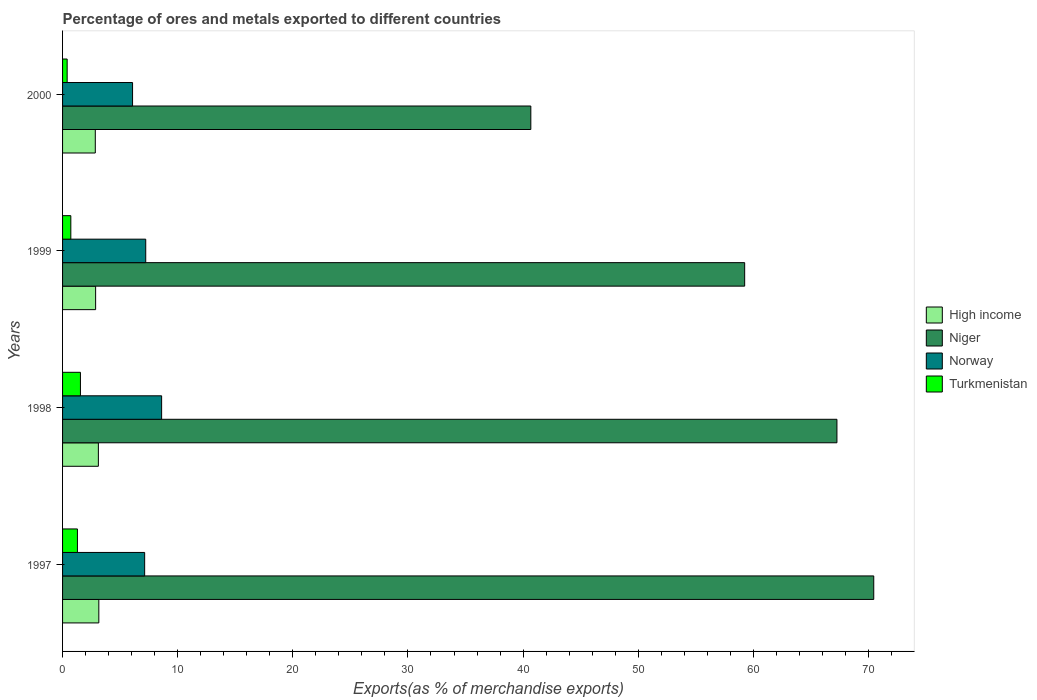How many groups of bars are there?
Your response must be concise. 4. Are the number of bars per tick equal to the number of legend labels?
Make the answer very short. Yes. How many bars are there on the 4th tick from the bottom?
Give a very brief answer. 4. What is the label of the 4th group of bars from the top?
Make the answer very short. 1997. In how many cases, is the number of bars for a given year not equal to the number of legend labels?
Keep it short and to the point. 0. What is the percentage of exports to different countries in Norway in 2000?
Make the answer very short. 6.08. Across all years, what is the maximum percentage of exports to different countries in High income?
Your answer should be very brief. 3.15. Across all years, what is the minimum percentage of exports to different countries in Norway?
Your answer should be compact. 6.08. In which year was the percentage of exports to different countries in Norway maximum?
Give a very brief answer. 1998. What is the total percentage of exports to different countries in High income in the graph?
Your answer should be very brief. 11.98. What is the difference between the percentage of exports to different countries in Norway in 1997 and that in 1998?
Provide a succinct answer. -1.47. What is the difference between the percentage of exports to different countries in Norway in 1998 and the percentage of exports to different countries in Turkmenistan in 1997?
Make the answer very short. 7.31. What is the average percentage of exports to different countries in Niger per year?
Offer a terse response. 59.41. In the year 1998, what is the difference between the percentage of exports to different countries in Niger and percentage of exports to different countries in Turkmenistan?
Keep it short and to the point. 65.71. What is the ratio of the percentage of exports to different countries in Niger in 1998 to that in 2000?
Offer a terse response. 1.65. Is the percentage of exports to different countries in Niger in 1997 less than that in 1998?
Make the answer very short. No. Is the difference between the percentage of exports to different countries in Niger in 1999 and 2000 greater than the difference between the percentage of exports to different countries in Turkmenistan in 1999 and 2000?
Keep it short and to the point. Yes. What is the difference between the highest and the second highest percentage of exports to different countries in Norway?
Provide a short and direct response. 1.38. What is the difference between the highest and the lowest percentage of exports to different countries in Norway?
Your answer should be compact. 2.52. Is the sum of the percentage of exports to different countries in High income in 1998 and 1999 greater than the maximum percentage of exports to different countries in Turkmenistan across all years?
Your response must be concise. Yes. Is it the case that in every year, the sum of the percentage of exports to different countries in High income and percentage of exports to different countries in Niger is greater than the percentage of exports to different countries in Turkmenistan?
Provide a short and direct response. Yes. What is the difference between two consecutive major ticks on the X-axis?
Your response must be concise. 10. Where does the legend appear in the graph?
Offer a very short reply. Center right. How many legend labels are there?
Provide a succinct answer. 4. How are the legend labels stacked?
Provide a short and direct response. Vertical. What is the title of the graph?
Provide a short and direct response. Percentage of ores and metals exported to different countries. Does "St. Lucia" appear as one of the legend labels in the graph?
Give a very brief answer. No. What is the label or title of the X-axis?
Your response must be concise. Exports(as % of merchandise exports). What is the Exports(as % of merchandise exports) of High income in 1997?
Offer a terse response. 3.15. What is the Exports(as % of merchandise exports) of Niger in 1997?
Keep it short and to the point. 70.46. What is the Exports(as % of merchandise exports) in Norway in 1997?
Provide a short and direct response. 7.13. What is the Exports(as % of merchandise exports) in Turkmenistan in 1997?
Make the answer very short. 1.29. What is the Exports(as % of merchandise exports) in High income in 1998?
Provide a succinct answer. 3.11. What is the Exports(as % of merchandise exports) of Niger in 1998?
Provide a short and direct response. 67.26. What is the Exports(as % of merchandise exports) in Norway in 1998?
Ensure brevity in your answer.  8.6. What is the Exports(as % of merchandise exports) in Turkmenistan in 1998?
Ensure brevity in your answer.  1.55. What is the Exports(as % of merchandise exports) in High income in 1999?
Offer a terse response. 2.87. What is the Exports(as % of merchandise exports) in Niger in 1999?
Make the answer very short. 59.25. What is the Exports(as % of merchandise exports) in Norway in 1999?
Provide a succinct answer. 7.22. What is the Exports(as % of merchandise exports) of Turkmenistan in 1999?
Give a very brief answer. 0.72. What is the Exports(as % of merchandise exports) in High income in 2000?
Offer a terse response. 2.84. What is the Exports(as % of merchandise exports) of Niger in 2000?
Give a very brief answer. 40.67. What is the Exports(as % of merchandise exports) of Norway in 2000?
Offer a terse response. 6.08. What is the Exports(as % of merchandise exports) of Turkmenistan in 2000?
Your response must be concise. 0.4. Across all years, what is the maximum Exports(as % of merchandise exports) of High income?
Make the answer very short. 3.15. Across all years, what is the maximum Exports(as % of merchandise exports) in Niger?
Make the answer very short. 70.46. Across all years, what is the maximum Exports(as % of merchandise exports) in Norway?
Ensure brevity in your answer.  8.6. Across all years, what is the maximum Exports(as % of merchandise exports) of Turkmenistan?
Keep it short and to the point. 1.55. Across all years, what is the minimum Exports(as % of merchandise exports) in High income?
Provide a short and direct response. 2.84. Across all years, what is the minimum Exports(as % of merchandise exports) in Niger?
Offer a terse response. 40.67. Across all years, what is the minimum Exports(as % of merchandise exports) of Norway?
Keep it short and to the point. 6.08. Across all years, what is the minimum Exports(as % of merchandise exports) of Turkmenistan?
Keep it short and to the point. 0.4. What is the total Exports(as % of merchandise exports) of High income in the graph?
Offer a terse response. 11.98. What is the total Exports(as % of merchandise exports) in Niger in the graph?
Provide a short and direct response. 237.64. What is the total Exports(as % of merchandise exports) in Norway in the graph?
Offer a very short reply. 29.04. What is the total Exports(as % of merchandise exports) of Turkmenistan in the graph?
Provide a succinct answer. 3.96. What is the difference between the Exports(as % of merchandise exports) of High income in 1997 and that in 1998?
Keep it short and to the point. 0.04. What is the difference between the Exports(as % of merchandise exports) in Niger in 1997 and that in 1998?
Offer a terse response. 3.2. What is the difference between the Exports(as % of merchandise exports) in Norway in 1997 and that in 1998?
Your response must be concise. -1.47. What is the difference between the Exports(as % of merchandise exports) of Turkmenistan in 1997 and that in 1998?
Offer a very short reply. -0.26. What is the difference between the Exports(as % of merchandise exports) of High income in 1997 and that in 1999?
Your answer should be very brief. 0.28. What is the difference between the Exports(as % of merchandise exports) of Niger in 1997 and that in 1999?
Provide a succinct answer. 11.21. What is the difference between the Exports(as % of merchandise exports) of Norway in 1997 and that in 1999?
Provide a short and direct response. -0.09. What is the difference between the Exports(as % of merchandise exports) of Turkmenistan in 1997 and that in 1999?
Keep it short and to the point. 0.57. What is the difference between the Exports(as % of merchandise exports) of High income in 1997 and that in 2000?
Make the answer very short. 0.31. What is the difference between the Exports(as % of merchandise exports) of Niger in 1997 and that in 2000?
Provide a short and direct response. 29.79. What is the difference between the Exports(as % of merchandise exports) of Norway in 1997 and that in 2000?
Give a very brief answer. 1.05. What is the difference between the Exports(as % of merchandise exports) of Turkmenistan in 1997 and that in 2000?
Offer a terse response. 0.89. What is the difference between the Exports(as % of merchandise exports) of High income in 1998 and that in 1999?
Your answer should be compact. 0.24. What is the difference between the Exports(as % of merchandise exports) of Niger in 1998 and that in 1999?
Ensure brevity in your answer.  8.01. What is the difference between the Exports(as % of merchandise exports) of Norway in 1998 and that in 1999?
Give a very brief answer. 1.38. What is the difference between the Exports(as % of merchandise exports) of Turkmenistan in 1998 and that in 1999?
Offer a terse response. 0.83. What is the difference between the Exports(as % of merchandise exports) in High income in 1998 and that in 2000?
Provide a short and direct response. 0.27. What is the difference between the Exports(as % of merchandise exports) in Niger in 1998 and that in 2000?
Offer a terse response. 26.59. What is the difference between the Exports(as % of merchandise exports) in Norway in 1998 and that in 2000?
Your answer should be very brief. 2.52. What is the difference between the Exports(as % of merchandise exports) of Turkmenistan in 1998 and that in 2000?
Give a very brief answer. 1.15. What is the difference between the Exports(as % of merchandise exports) in High income in 1999 and that in 2000?
Your answer should be very brief. 0.03. What is the difference between the Exports(as % of merchandise exports) of Niger in 1999 and that in 2000?
Give a very brief answer. 18.57. What is the difference between the Exports(as % of merchandise exports) in Norway in 1999 and that in 2000?
Provide a succinct answer. 1.14. What is the difference between the Exports(as % of merchandise exports) of Turkmenistan in 1999 and that in 2000?
Make the answer very short. 0.32. What is the difference between the Exports(as % of merchandise exports) of High income in 1997 and the Exports(as % of merchandise exports) of Niger in 1998?
Offer a very short reply. -64.11. What is the difference between the Exports(as % of merchandise exports) in High income in 1997 and the Exports(as % of merchandise exports) in Norway in 1998?
Offer a terse response. -5.45. What is the difference between the Exports(as % of merchandise exports) in High income in 1997 and the Exports(as % of merchandise exports) in Turkmenistan in 1998?
Offer a terse response. 1.6. What is the difference between the Exports(as % of merchandise exports) of Niger in 1997 and the Exports(as % of merchandise exports) of Norway in 1998?
Provide a short and direct response. 61.85. What is the difference between the Exports(as % of merchandise exports) of Niger in 1997 and the Exports(as % of merchandise exports) of Turkmenistan in 1998?
Your response must be concise. 68.91. What is the difference between the Exports(as % of merchandise exports) of Norway in 1997 and the Exports(as % of merchandise exports) of Turkmenistan in 1998?
Your answer should be compact. 5.58. What is the difference between the Exports(as % of merchandise exports) in High income in 1997 and the Exports(as % of merchandise exports) in Niger in 1999?
Make the answer very short. -56.1. What is the difference between the Exports(as % of merchandise exports) of High income in 1997 and the Exports(as % of merchandise exports) of Norway in 1999?
Your answer should be compact. -4.07. What is the difference between the Exports(as % of merchandise exports) of High income in 1997 and the Exports(as % of merchandise exports) of Turkmenistan in 1999?
Offer a terse response. 2.43. What is the difference between the Exports(as % of merchandise exports) in Niger in 1997 and the Exports(as % of merchandise exports) in Norway in 1999?
Offer a terse response. 63.23. What is the difference between the Exports(as % of merchandise exports) in Niger in 1997 and the Exports(as % of merchandise exports) in Turkmenistan in 1999?
Your answer should be compact. 69.74. What is the difference between the Exports(as % of merchandise exports) in Norway in 1997 and the Exports(as % of merchandise exports) in Turkmenistan in 1999?
Offer a terse response. 6.41. What is the difference between the Exports(as % of merchandise exports) of High income in 1997 and the Exports(as % of merchandise exports) of Niger in 2000?
Offer a very short reply. -37.52. What is the difference between the Exports(as % of merchandise exports) of High income in 1997 and the Exports(as % of merchandise exports) of Norway in 2000?
Provide a short and direct response. -2.93. What is the difference between the Exports(as % of merchandise exports) of High income in 1997 and the Exports(as % of merchandise exports) of Turkmenistan in 2000?
Give a very brief answer. 2.75. What is the difference between the Exports(as % of merchandise exports) in Niger in 1997 and the Exports(as % of merchandise exports) in Norway in 2000?
Provide a succinct answer. 64.38. What is the difference between the Exports(as % of merchandise exports) in Niger in 1997 and the Exports(as % of merchandise exports) in Turkmenistan in 2000?
Make the answer very short. 70.06. What is the difference between the Exports(as % of merchandise exports) of Norway in 1997 and the Exports(as % of merchandise exports) of Turkmenistan in 2000?
Offer a very short reply. 6.73. What is the difference between the Exports(as % of merchandise exports) in High income in 1998 and the Exports(as % of merchandise exports) in Niger in 1999?
Make the answer very short. -56.14. What is the difference between the Exports(as % of merchandise exports) in High income in 1998 and the Exports(as % of merchandise exports) in Norway in 1999?
Provide a succinct answer. -4.11. What is the difference between the Exports(as % of merchandise exports) in High income in 1998 and the Exports(as % of merchandise exports) in Turkmenistan in 1999?
Your answer should be compact. 2.39. What is the difference between the Exports(as % of merchandise exports) in Niger in 1998 and the Exports(as % of merchandise exports) in Norway in 1999?
Your answer should be very brief. 60.04. What is the difference between the Exports(as % of merchandise exports) in Niger in 1998 and the Exports(as % of merchandise exports) in Turkmenistan in 1999?
Offer a terse response. 66.54. What is the difference between the Exports(as % of merchandise exports) in Norway in 1998 and the Exports(as % of merchandise exports) in Turkmenistan in 1999?
Ensure brevity in your answer.  7.89. What is the difference between the Exports(as % of merchandise exports) of High income in 1998 and the Exports(as % of merchandise exports) of Niger in 2000?
Offer a very short reply. -37.56. What is the difference between the Exports(as % of merchandise exports) of High income in 1998 and the Exports(as % of merchandise exports) of Norway in 2000?
Ensure brevity in your answer.  -2.97. What is the difference between the Exports(as % of merchandise exports) of High income in 1998 and the Exports(as % of merchandise exports) of Turkmenistan in 2000?
Your response must be concise. 2.71. What is the difference between the Exports(as % of merchandise exports) in Niger in 1998 and the Exports(as % of merchandise exports) in Norway in 2000?
Give a very brief answer. 61.18. What is the difference between the Exports(as % of merchandise exports) in Niger in 1998 and the Exports(as % of merchandise exports) in Turkmenistan in 2000?
Ensure brevity in your answer.  66.86. What is the difference between the Exports(as % of merchandise exports) of Norway in 1998 and the Exports(as % of merchandise exports) of Turkmenistan in 2000?
Ensure brevity in your answer.  8.21. What is the difference between the Exports(as % of merchandise exports) in High income in 1999 and the Exports(as % of merchandise exports) in Niger in 2000?
Make the answer very short. -37.8. What is the difference between the Exports(as % of merchandise exports) in High income in 1999 and the Exports(as % of merchandise exports) in Norway in 2000?
Your response must be concise. -3.21. What is the difference between the Exports(as % of merchandise exports) in High income in 1999 and the Exports(as % of merchandise exports) in Turkmenistan in 2000?
Your answer should be compact. 2.47. What is the difference between the Exports(as % of merchandise exports) in Niger in 1999 and the Exports(as % of merchandise exports) in Norway in 2000?
Provide a succinct answer. 53.17. What is the difference between the Exports(as % of merchandise exports) in Niger in 1999 and the Exports(as % of merchandise exports) in Turkmenistan in 2000?
Offer a terse response. 58.85. What is the difference between the Exports(as % of merchandise exports) in Norway in 1999 and the Exports(as % of merchandise exports) in Turkmenistan in 2000?
Your response must be concise. 6.82. What is the average Exports(as % of merchandise exports) in High income per year?
Your response must be concise. 2.99. What is the average Exports(as % of merchandise exports) of Niger per year?
Keep it short and to the point. 59.41. What is the average Exports(as % of merchandise exports) in Norway per year?
Offer a terse response. 7.26. In the year 1997, what is the difference between the Exports(as % of merchandise exports) of High income and Exports(as % of merchandise exports) of Niger?
Offer a very short reply. -67.31. In the year 1997, what is the difference between the Exports(as % of merchandise exports) in High income and Exports(as % of merchandise exports) in Norway?
Offer a terse response. -3.98. In the year 1997, what is the difference between the Exports(as % of merchandise exports) in High income and Exports(as % of merchandise exports) in Turkmenistan?
Provide a succinct answer. 1.86. In the year 1997, what is the difference between the Exports(as % of merchandise exports) in Niger and Exports(as % of merchandise exports) in Norway?
Offer a terse response. 63.33. In the year 1997, what is the difference between the Exports(as % of merchandise exports) in Niger and Exports(as % of merchandise exports) in Turkmenistan?
Provide a short and direct response. 69.17. In the year 1997, what is the difference between the Exports(as % of merchandise exports) in Norway and Exports(as % of merchandise exports) in Turkmenistan?
Provide a succinct answer. 5.84. In the year 1998, what is the difference between the Exports(as % of merchandise exports) of High income and Exports(as % of merchandise exports) of Niger?
Your response must be concise. -64.15. In the year 1998, what is the difference between the Exports(as % of merchandise exports) of High income and Exports(as % of merchandise exports) of Norway?
Keep it short and to the point. -5.49. In the year 1998, what is the difference between the Exports(as % of merchandise exports) of High income and Exports(as % of merchandise exports) of Turkmenistan?
Offer a very short reply. 1.56. In the year 1998, what is the difference between the Exports(as % of merchandise exports) of Niger and Exports(as % of merchandise exports) of Norway?
Give a very brief answer. 58.66. In the year 1998, what is the difference between the Exports(as % of merchandise exports) in Niger and Exports(as % of merchandise exports) in Turkmenistan?
Provide a succinct answer. 65.71. In the year 1998, what is the difference between the Exports(as % of merchandise exports) of Norway and Exports(as % of merchandise exports) of Turkmenistan?
Offer a very short reply. 7.05. In the year 1999, what is the difference between the Exports(as % of merchandise exports) of High income and Exports(as % of merchandise exports) of Niger?
Your answer should be compact. -56.38. In the year 1999, what is the difference between the Exports(as % of merchandise exports) in High income and Exports(as % of merchandise exports) in Norway?
Ensure brevity in your answer.  -4.35. In the year 1999, what is the difference between the Exports(as % of merchandise exports) of High income and Exports(as % of merchandise exports) of Turkmenistan?
Provide a succinct answer. 2.15. In the year 1999, what is the difference between the Exports(as % of merchandise exports) of Niger and Exports(as % of merchandise exports) of Norway?
Ensure brevity in your answer.  52.02. In the year 1999, what is the difference between the Exports(as % of merchandise exports) in Niger and Exports(as % of merchandise exports) in Turkmenistan?
Offer a terse response. 58.53. In the year 1999, what is the difference between the Exports(as % of merchandise exports) of Norway and Exports(as % of merchandise exports) of Turkmenistan?
Offer a terse response. 6.51. In the year 2000, what is the difference between the Exports(as % of merchandise exports) in High income and Exports(as % of merchandise exports) in Niger?
Your response must be concise. -37.83. In the year 2000, what is the difference between the Exports(as % of merchandise exports) of High income and Exports(as % of merchandise exports) of Norway?
Make the answer very short. -3.24. In the year 2000, what is the difference between the Exports(as % of merchandise exports) of High income and Exports(as % of merchandise exports) of Turkmenistan?
Provide a short and direct response. 2.44. In the year 2000, what is the difference between the Exports(as % of merchandise exports) of Niger and Exports(as % of merchandise exports) of Norway?
Make the answer very short. 34.59. In the year 2000, what is the difference between the Exports(as % of merchandise exports) in Niger and Exports(as % of merchandise exports) in Turkmenistan?
Offer a terse response. 40.27. In the year 2000, what is the difference between the Exports(as % of merchandise exports) of Norway and Exports(as % of merchandise exports) of Turkmenistan?
Ensure brevity in your answer.  5.68. What is the ratio of the Exports(as % of merchandise exports) in High income in 1997 to that in 1998?
Your response must be concise. 1.01. What is the ratio of the Exports(as % of merchandise exports) in Niger in 1997 to that in 1998?
Your answer should be very brief. 1.05. What is the ratio of the Exports(as % of merchandise exports) of Norway in 1997 to that in 1998?
Keep it short and to the point. 0.83. What is the ratio of the Exports(as % of merchandise exports) in Turkmenistan in 1997 to that in 1998?
Give a very brief answer. 0.83. What is the ratio of the Exports(as % of merchandise exports) of High income in 1997 to that in 1999?
Your answer should be very brief. 1.1. What is the ratio of the Exports(as % of merchandise exports) in Niger in 1997 to that in 1999?
Ensure brevity in your answer.  1.19. What is the ratio of the Exports(as % of merchandise exports) in Norway in 1997 to that in 1999?
Offer a very short reply. 0.99. What is the ratio of the Exports(as % of merchandise exports) in Turkmenistan in 1997 to that in 1999?
Offer a very short reply. 1.8. What is the ratio of the Exports(as % of merchandise exports) of High income in 1997 to that in 2000?
Your answer should be compact. 1.11. What is the ratio of the Exports(as % of merchandise exports) of Niger in 1997 to that in 2000?
Provide a succinct answer. 1.73. What is the ratio of the Exports(as % of merchandise exports) in Norway in 1997 to that in 2000?
Ensure brevity in your answer.  1.17. What is the ratio of the Exports(as % of merchandise exports) in Turkmenistan in 1997 to that in 2000?
Offer a very short reply. 3.24. What is the ratio of the Exports(as % of merchandise exports) in High income in 1998 to that in 1999?
Keep it short and to the point. 1.08. What is the ratio of the Exports(as % of merchandise exports) of Niger in 1998 to that in 1999?
Your answer should be compact. 1.14. What is the ratio of the Exports(as % of merchandise exports) in Norway in 1998 to that in 1999?
Give a very brief answer. 1.19. What is the ratio of the Exports(as % of merchandise exports) of Turkmenistan in 1998 to that in 1999?
Provide a succinct answer. 2.16. What is the ratio of the Exports(as % of merchandise exports) of High income in 1998 to that in 2000?
Offer a very short reply. 1.09. What is the ratio of the Exports(as % of merchandise exports) in Niger in 1998 to that in 2000?
Ensure brevity in your answer.  1.65. What is the ratio of the Exports(as % of merchandise exports) in Norway in 1998 to that in 2000?
Provide a short and direct response. 1.42. What is the ratio of the Exports(as % of merchandise exports) in Turkmenistan in 1998 to that in 2000?
Keep it short and to the point. 3.89. What is the ratio of the Exports(as % of merchandise exports) of High income in 1999 to that in 2000?
Provide a short and direct response. 1.01. What is the ratio of the Exports(as % of merchandise exports) in Niger in 1999 to that in 2000?
Make the answer very short. 1.46. What is the ratio of the Exports(as % of merchandise exports) in Norway in 1999 to that in 2000?
Offer a very short reply. 1.19. What is the ratio of the Exports(as % of merchandise exports) of Turkmenistan in 1999 to that in 2000?
Your answer should be very brief. 1.8. What is the difference between the highest and the second highest Exports(as % of merchandise exports) of High income?
Offer a very short reply. 0.04. What is the difference between the highest and the second highest Exports(as % of merchandise exports) of Niger?
Give a very brief answer. 3.2. What is the difference between the highest and the second highest Exports(as % of merchandise exports) of Norway?
Provide a succinct answer. 1.38. What is the difference between the highest and the second highest Exports(as % of merchandise exports) of Turkmenistan?
Your response must be concise. 0.26. What is the difference between the highest and the lowest Exports(as % of merchandise exports) of High income?
Your answer should be very brief. 0.31. What is the difference between the highest and the lowest Exports(as % of merchandise exports) of Niger?
Keep it short and to the point. 29.79. What is the difference between the highest and the lowest Exports(as % of merchandise exports) of Norway?
Ensure brevity in your answer.  2.52. What is the difference between the highest and the lowest Exports(as % of merchandise exports) of Turkmenistan?
Ensure brevity in your answer.  1.15. 